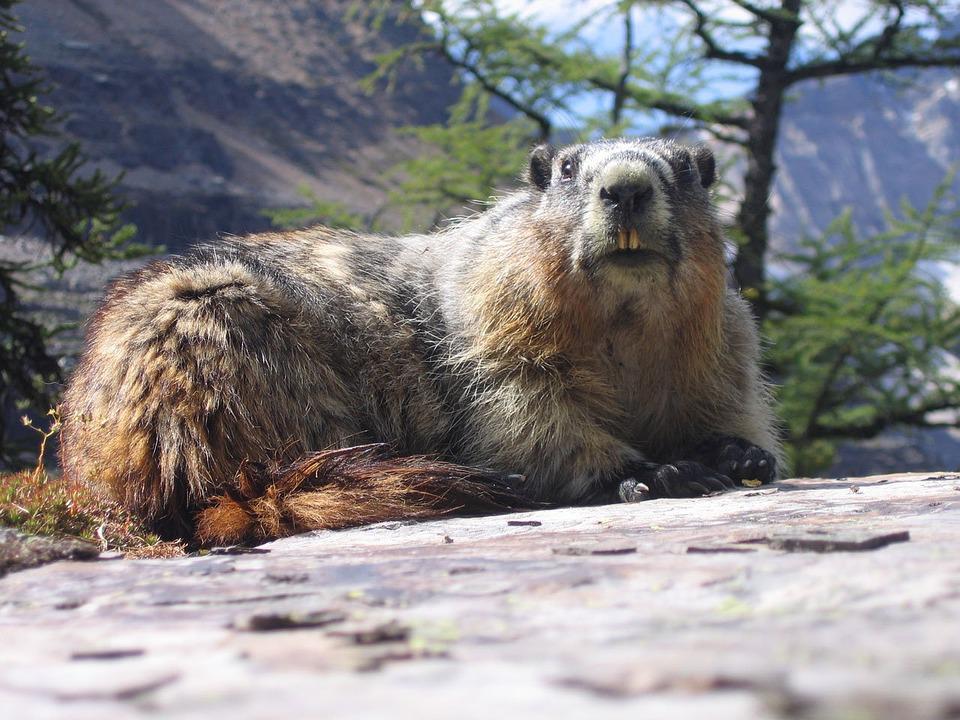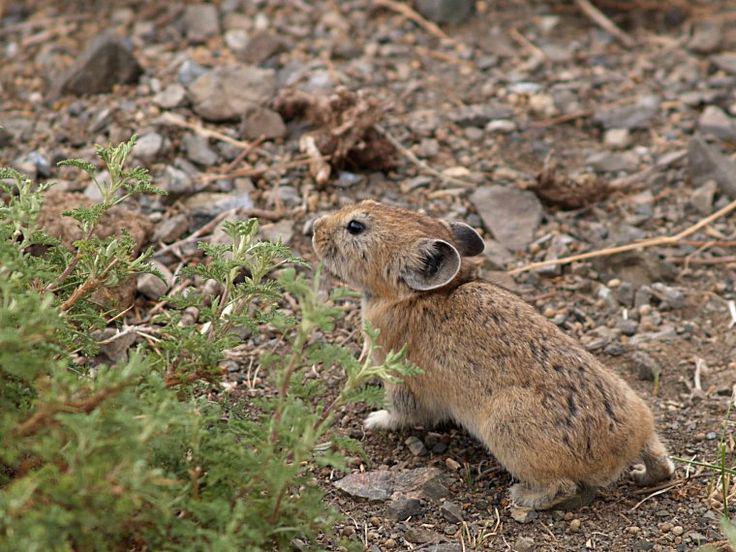The first image is the image on the left, the second image is the image on the right. Analyze the images presented: Is the assertion "The marmot in the left image is upright with food clasped in its paws, and the marmot on the right is standing on all fours on the ground." valid? Answer yes or no. No. The first image is the image on the left, the second image is the image on the right. Considering the images on both sides, is "The animal in the image on the left is holding something to its mouth." valid? Answer yes or no. No. 